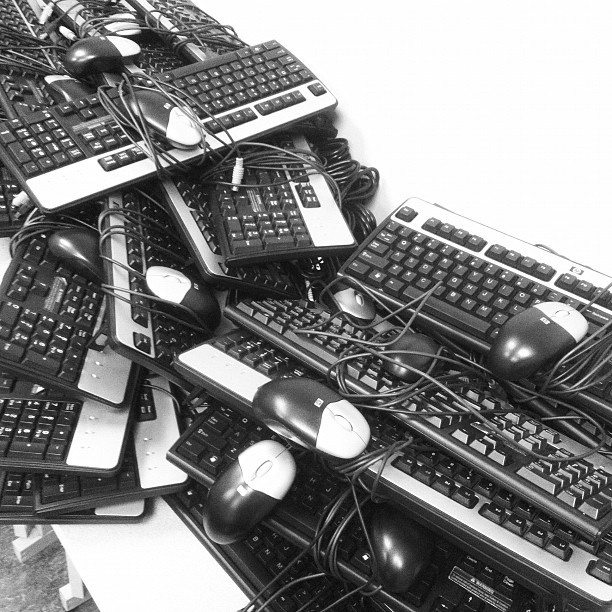Describe the objects in this image and their specific colors. I can see keyboard in black, gray, darkgray, and lightgray tones, keyboard in black, gray, white, and darkgray tones, keyboard in black, gray, white, and darkgray tones, keyboard in black, gray, whitesmoke, and darkgray tones, and keyboard in black, lightgray, gray, and darkgray tones in this image. 